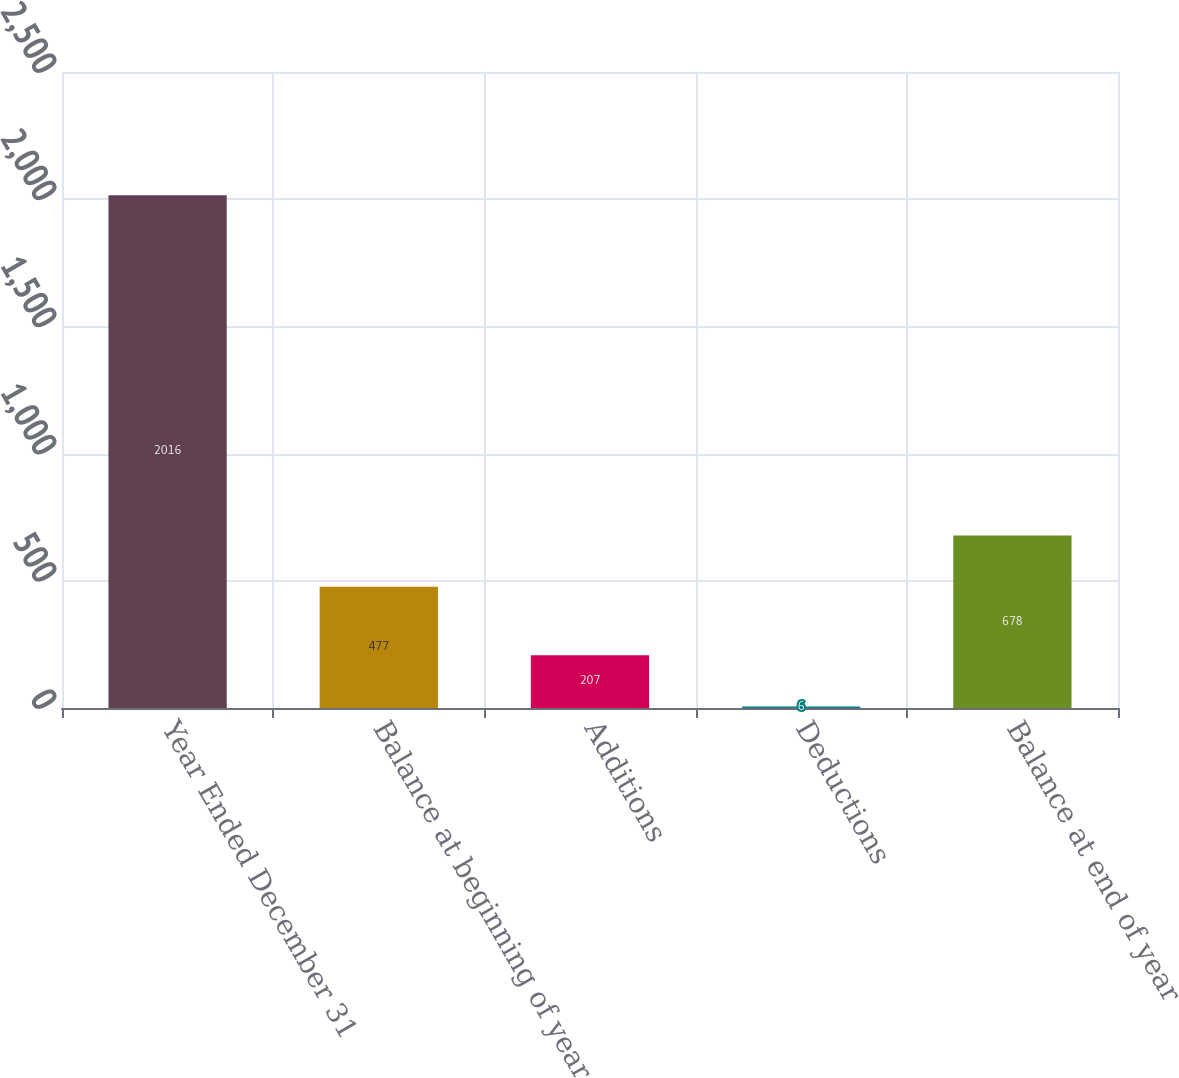Convert chart. <chart><loc_0><loc_0><loc_500><loc_500><bar_chart><fcel>Year Ended December 31<fcel>Balance at beginning of year<fcel>Additions<fcel>Deductions<fcel>Balance at end of year<nl><fcel>2016<fcel>477<fcel>207<fcel>6<fcel>678<nl></chart> 